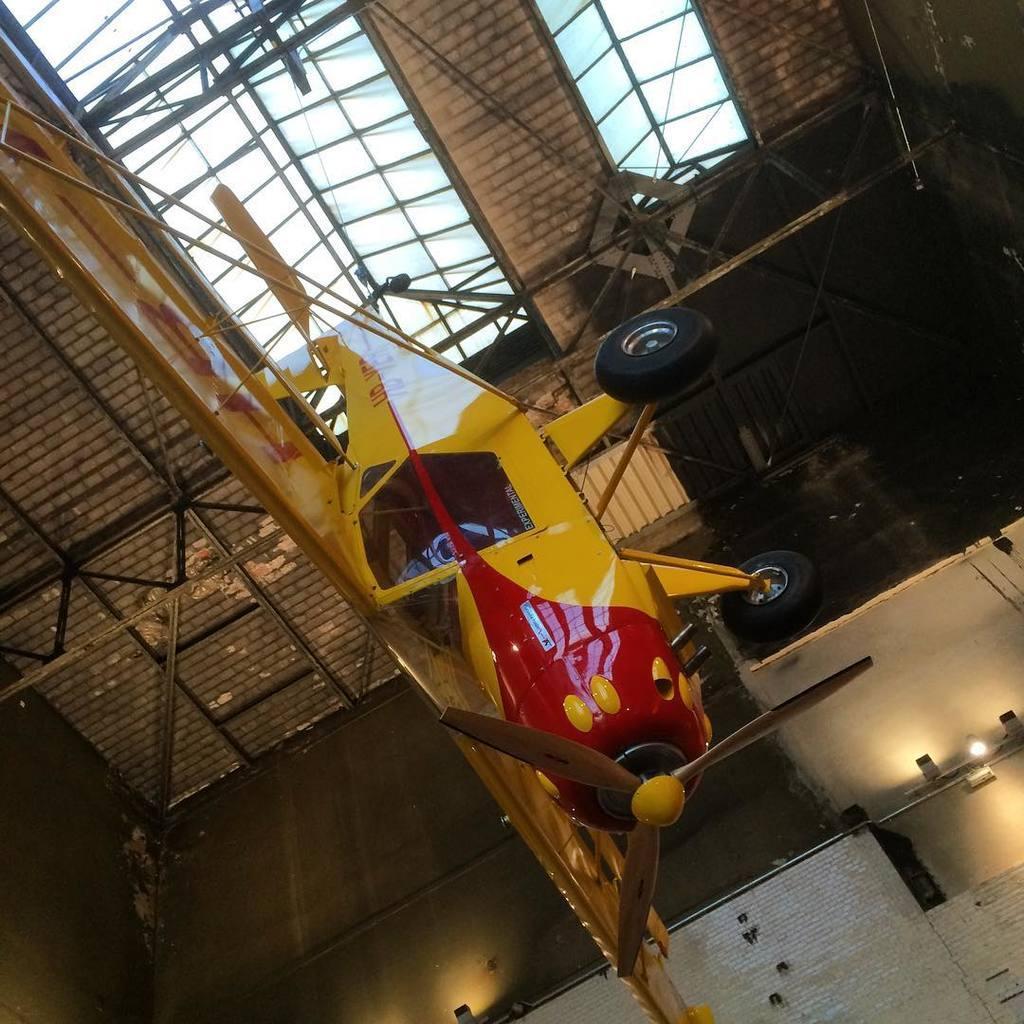Describe this image in one or two sentences. In this picture there is a red and yellow small aircraft is hanging from the ceiling. On the top there is an iron frame and glass. 